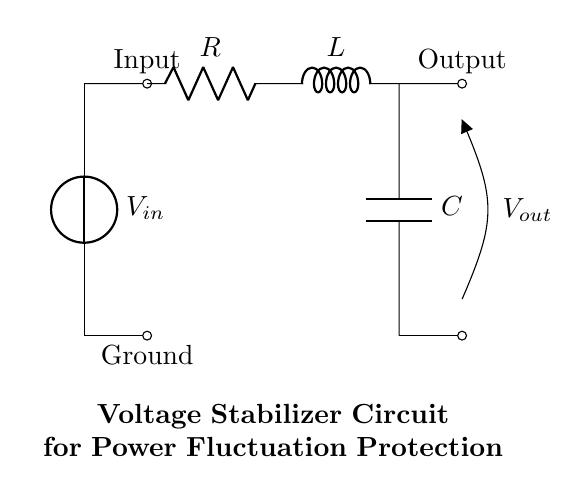What is the input voltage source in this circuit? The circuit contains a voltage source labeled as Vin, which represents the input voltage.
Answer: Vin What type of components are in this circuit? The circuit consists of a resistor (R), an inductor (L), and a capacitor (C), which are the essential components of a RLC circuit.
Answer: Resistor, Inductor, Capacitor What is the output of this voltage stabilizer circuit? The output is labeled as Vout, which is the stabilized voltage provided to sensitive equipment after processing the input voltage.
Answer: Vout How many main components are connected in series? The resistor, inductor, and capacitor are connected in series, which counts as three main components.
Answer: Three What is the function of the capacitor in this circuit? The capacitor in this circuit helps to smooth out fluctuations in voltage, providing stabilization during variations in the input voltage.
Answer: Stabilization What happens to voltage fluctuations in this circuit? The circuit stabilizes voltage fluctuations by using the combined behavior of the resistor, inductor, and capacitor to filter and regulate the output value.
Answer: Stabilizes What does the inductor primarily do in this circuit? The inductor primarily stores energy in the form of a magnetic field and resists changes in current, helping to regulate the voltage stability in the circuit.
Answer: Stores energy 